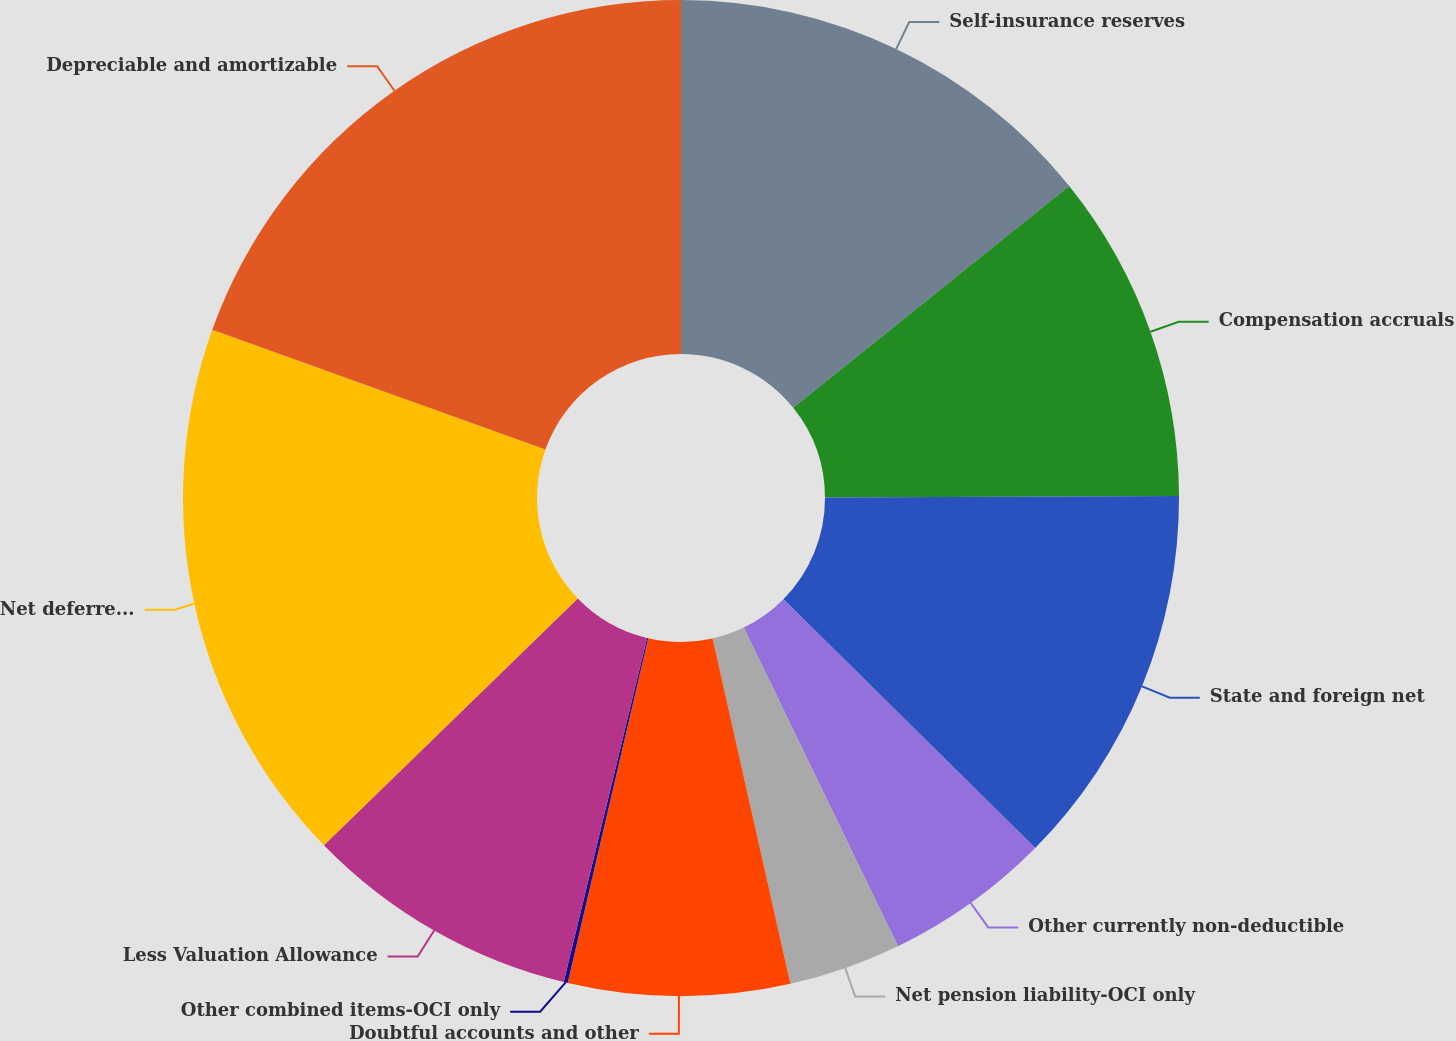Convert chart to OTSL. <chart><loc_0><loc_0><loc_500><loc_500><pie_chart><fcel>Self-insurance reserves<fcel>Compensation accruals<fcel>State and foreign net<fcel>Other currently non-deductible<fcel>Net pension liability-OCI only<fcel>Doubtful accounts and other<fcel>Other combined items-OCI only<fcel>Less Valuation Allowance<fcel>Net deferred income tax assets<fcel>Depreciable and amortizable<nl><fcel>14.23%<fcel>10.71%<fcel>12.47%<fcel>5.42%<fcel>3.65%<fcel>7.18%<fcel>0.13%<fcel>8.94%<fcel>17.76%<fcel>19.52%<nl></chart> 